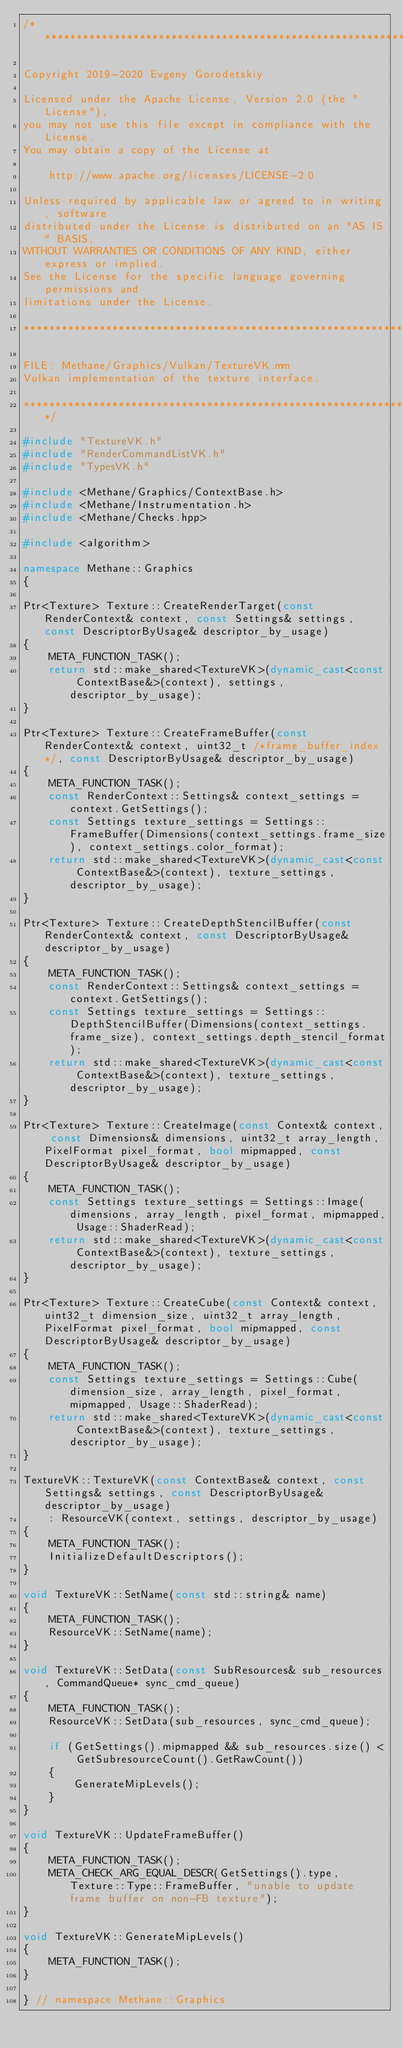Convert code to text. <code><loc_0><loc_0><loc_500><loc_500><_C++_>/******************************************************************************

Copyright 2019-2020 Evgeny Gorodetskiy

Licensed under the Apache License, Version 2.0 (the "License"),
you may not use this file except in compliance with the License.
You may obtain a copy of the License at

    http://www.apache.org/licenses/LICENSE-2.0

Unless required by applicable law or agreed to in writing, software
distributed under the License is distributed on an "AS IS" BASIS,
WITHOUT WARRANTIES OR CONDITIONS OF ANY KIND, either express or implied.
See the License for the specific language governing permissions and
limitations under the License.

*******************************************************************************

FILE: Methane/Graphics/Vulkan/TextureVK.mm
Vulkan implementation of the texture interface.

******************************************************************************/

#include "TextureVK.h"
#include "RenderCommandListVK.h"
#include "TypesVK.h"

#include <Methane/Graphics/ContextBase.h>
#include <Methane/Instrumentation.h>
#include <Methane/Checks.hpp>

#include <algorithm>

namespace Methane::Graphics
{

Ptr<Texture> Texture::CreateRenderTarget(const RenderContext& context, const Settings& settings, const DescriptorByUsage& descriptor_by_usage)
{
    META_FUNCTION_TASK();
    return std::make_shared<TextureVK>(dynamic_cast<const ContextBase&>(context), settings, descriptor_by_usage);
}

Ptr<Texture> Texture::CreateFrameBuffer(const RenderContext& context, uint32_t /*frame_buffer_index*/, const DescriptorByUsage& descriptor_by_usage)
{
    META_FUNCTION_TASK();
    const RenderContext::Settings& context_settings = context.GetSettings();
    const Settings texture_settings = Settings::FrameBuffer(Dimensions(context_settings.frame_size), context_settings.color_format);
    return std::make_shared<TextureVK>(dynamic_cast<const ContextBase&>(context), texture_settings, descriptor_by_usage);
}

Ptr<Texture> Texture::CreateDepthStencilBuffer(const RenderContext& context, const DescriptorByUsage& descriptor_by_usage)
{
    META_FUNCTION_TASK();
    const RenderContext::Settings& context_settings = context.GetSettings();
    const Settings texture_settings = Settings::DepthStencilBuffer(Dimensions(context_settings.frame_size), context_settings.depth_stencil_format);
    return std::make_shared<TextureVK>(dynamic_cast<const ContextBase&>(context), texture_settings, descriptor_by_usage);
}

Ptr<Texture> Texture::CreateImage(const Context& context, const Dimensions& dimensions, uint32_t array_length, PixelFormat pixel_format, bool mipmapped, const DescriptorByUsage& descriptor_by_usage)
{
    META_FUNCTION_TASK();
    const Settings texture_settings = Settings::Image(dimensions, array_length, pixel_format, mipmapped, Usage::ShaderRead);
    return std::make_shared<TextureVK>(dynamic_cast<const ContextBase&>(context), texture_settings, descriptor_by_usage);
}

Ptr<Texture> Texture::CreateCube(const Context& context, uint32_t dimension_size, uint32_t array_length, PixelFormat pixel_format, bool mipmapped, const DescriptorByUsage& descriptor_by_usage)
{
    META_FUNCTION_TASK();
    const Settings texture_settings = Settings::Cube(dimension_size, array_length, pixel_format, mipmapped, Usage::ShaderRead);
    return std::make_shared<TextureVK>(dynamic_cast<const ContextBase&>(context), texture_settings, descriptor_by_usage);
}

TextureVK::TextureVK(const ContextBase& context, const Settings& settings, const DescriptorByUsage& descriptor_by_usage)
    : ResourceVK(context, settings, descriptor_by_usage)
{
    META_FUNCTION_TASK();
    InitializeDefaultDescriptors();
}

void TextureVK::SetName(const std::string& name)
{
    META_FUNCTION_TASK();
    ResourceVK::SetName(name);
}

void TextureVK::SetData(const SubResources& sub_resources, CommandQueue* sync_cmd_queue)
{
    META_FUNCTION_TASK();
    ResourceVK::SetData(sub_resources, sync_cmd_queue);
    
    if (GetSettings().mipmapped && sub_resources.size() < GetSubresourceCount().GetRawCount())
    {
        GenerateMipLevels();
    }
}

void TextureVK::UpdateFrameBuffer()
{
    META_FUNCTION_TASK();
    META_CHECK_ARG_EQUAL_DESCR(GetSettings().type, Texture::Type::FrameBuffer, "unable to update frame buffer on non-FB texture");
}

void TextureVK::GenerateMipLevels()
{
    META_FUNCTION_TASK();
}

} // namespace Methane::Graphics
</code> 